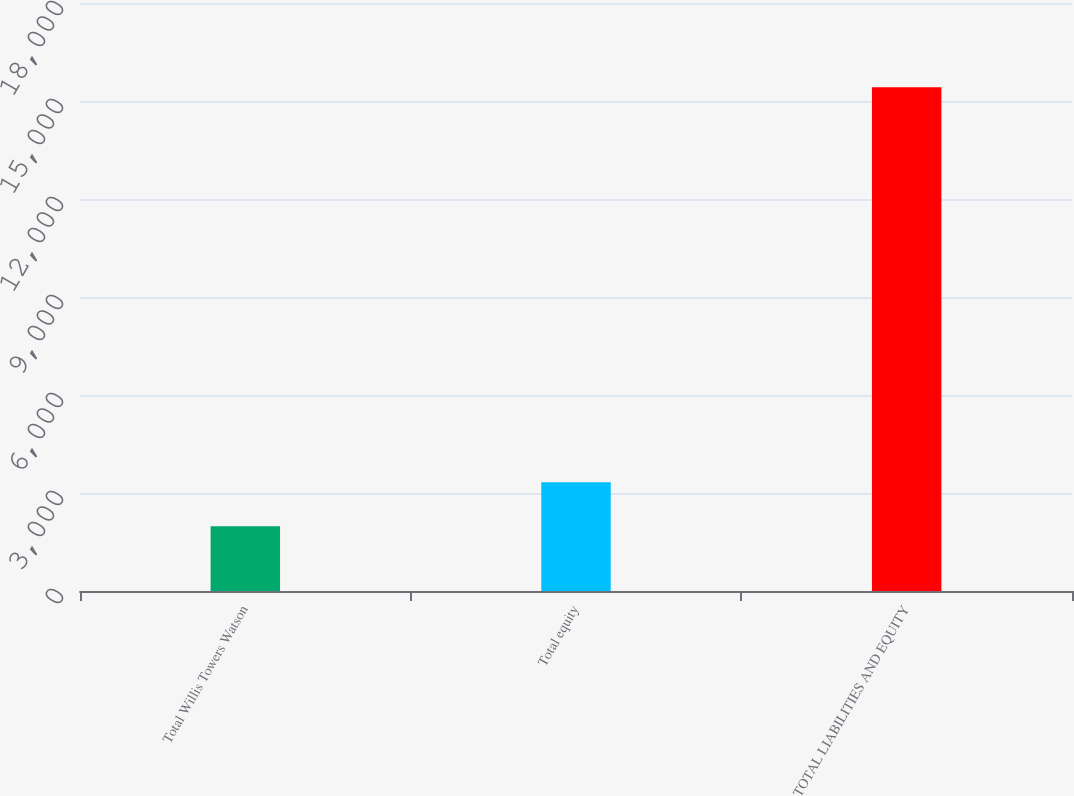<chart> <loc_0><loc_0><loc_500><loc_500><bar_chart><fcel>Total Willis Towers Watson<fcel>Total equity<fcel>TOTAL LIABILITIES AND EQUITY<nl><fcel>1985<fcel>3328.6<fcel>15421<nl></chart> 